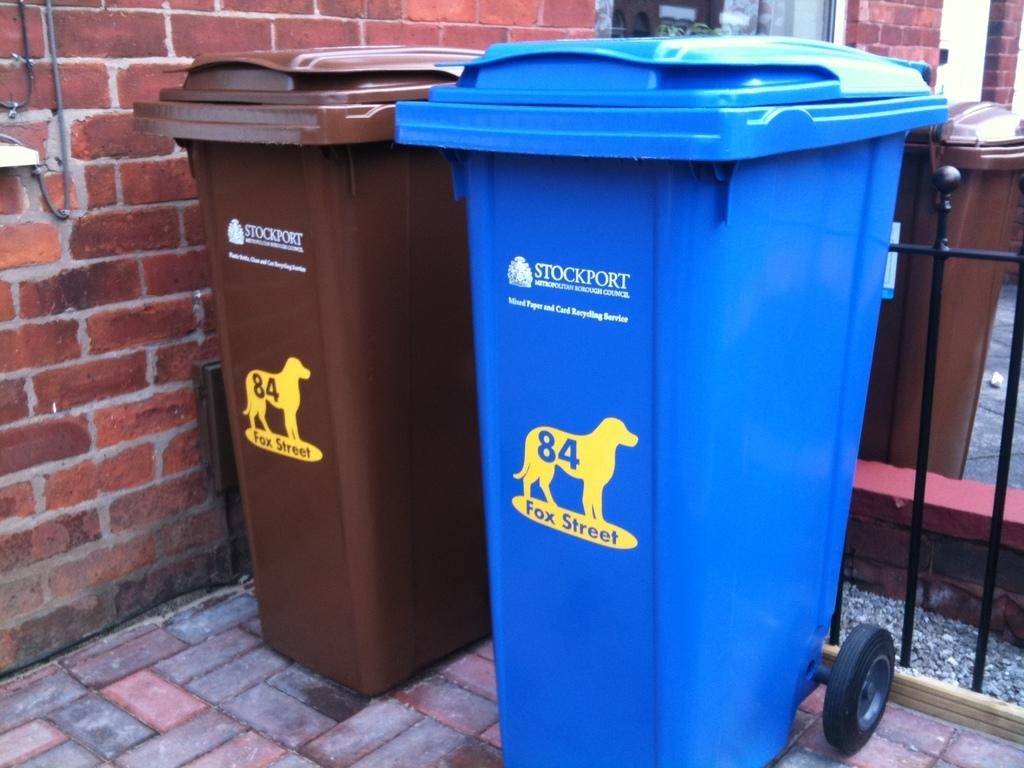<image>
Share a concise interpretation of the image provided. The garbage bins have the image of a dog and the words Fox Street on them. 